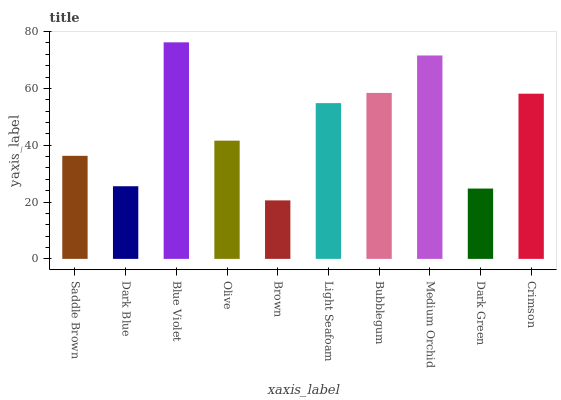Is Brown the minimum?
Answer yes or no. Yes. Is Blue Violet the maximum?
Answer yes or no. Yes. Is Dark Blue the minimum?
Answer yes or no. No. Is Dark Blue the maximum?
Answer yes or no. No. Is Saddle Brown greater than Dark Blue?
Answer yes or no. Yes. Is Dark Blue less than Saddle Brown?
Answer yes or no. Yes. Is Dark Blue greater than Saddle Brown?
Answer yes or no. No. Is Saddle Brown less than Dark Blue?
Answer yes or no. No. Is Light Seafoam the high median?
Answer yes or no. Yes. Is Olive the low median?
Answer yes or no. Yes. Is Olive the high median?
Answer yes or no. No. Is Medium Orchid the low median?
Answer yes or no. No. 